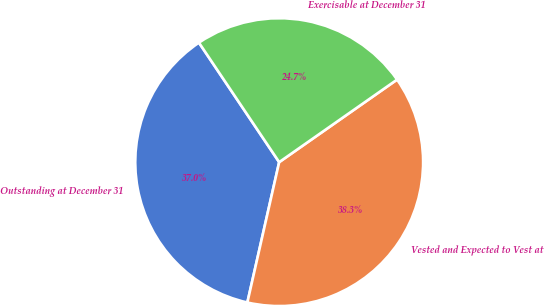Convert chart. <chart><loc_0><loc_0><loc_500><loc_500><pie_chart><fcel>Outstanding at December 31<fcel>Vested and Expected to Vest at<fcel>Exercisable at December 31<nl><fcel>37.04%<fcel>38.27%<fcel>24.69%<nl></chart> 